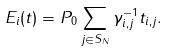<formula> <loc_0><loc_0><loc_500><loc_500>E _ { i } ( t ) = P _ { 0 } \sum _ { j \in S _ { N } } \gamma _ { i , j } ^ { - 1 } t _ { i , j } .</formula> 